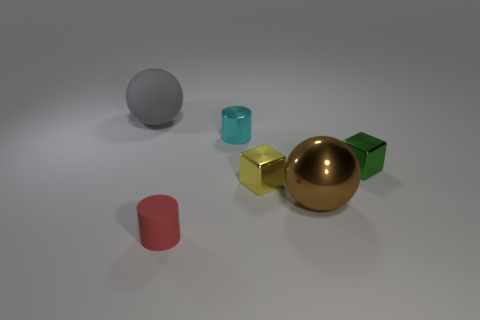Add 1 yellow blocks. How many objects exist? 7 Subtract all cylinders. How many objects are left? 4 Subtract 0 yellow cylinders. How many objects are left? 6 Subtract all big shiny balls. Subtract all blue cubes. How many objects are left? 5 Add 5 tiny cyan metallic objects. How many tiny cyan metallic objects are left? 6 Add 1 gray matte objects. How many gray matte objects exist? 2 